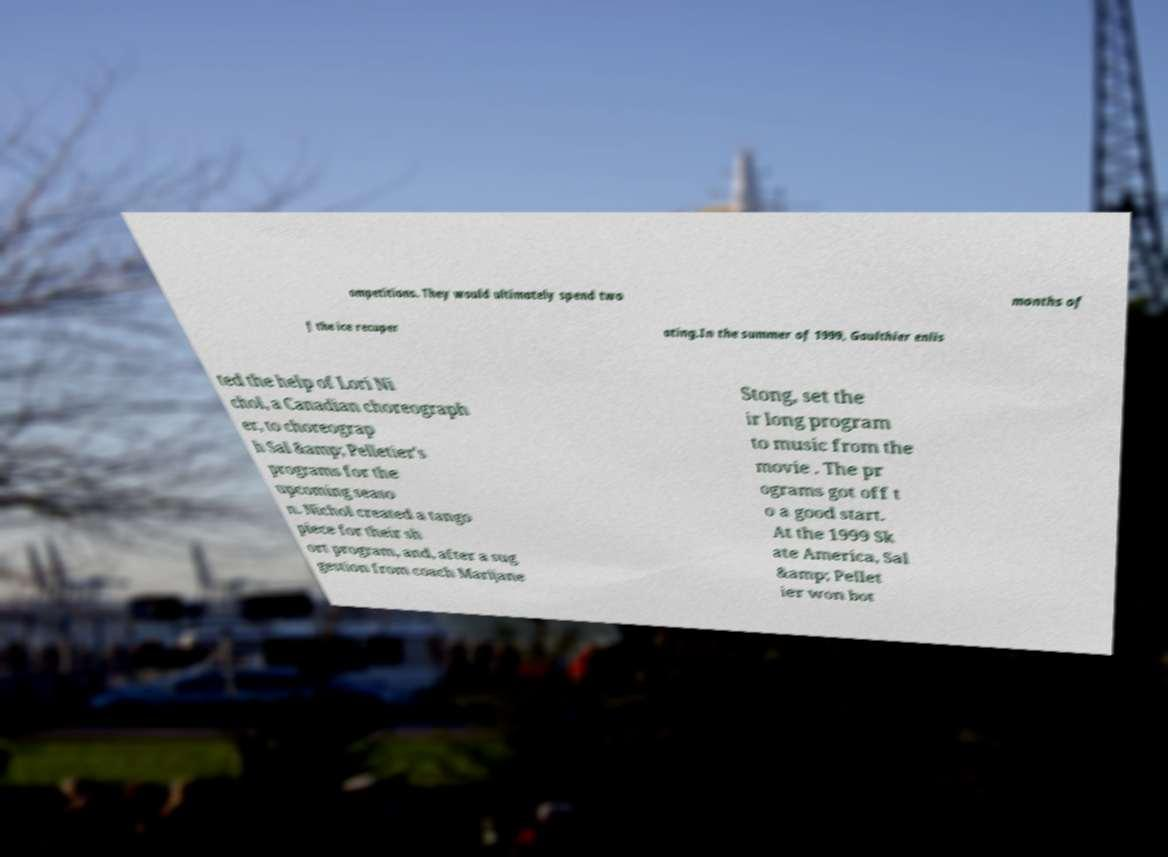Can you accurately transcribe the text from the provided image for me? ompetitions. They would ultimately spend two months of f the ice recuper ating.In the summer of 1999, Gaulthier enlis ted the help of Lori Ni chol, a Canadian choreograph er, to choreograp h Sal &amp; Pelletier's programs for the upcoming seaso n. Nichol created a tango piece for their sh ort program, and, after a sug gestion from coach Marijane Stong, set the ir long program to music from the movie . The pr ograms got off t o a good start. At the 1999 Sk ate America, Sal &amp; Pellet ier won bot 